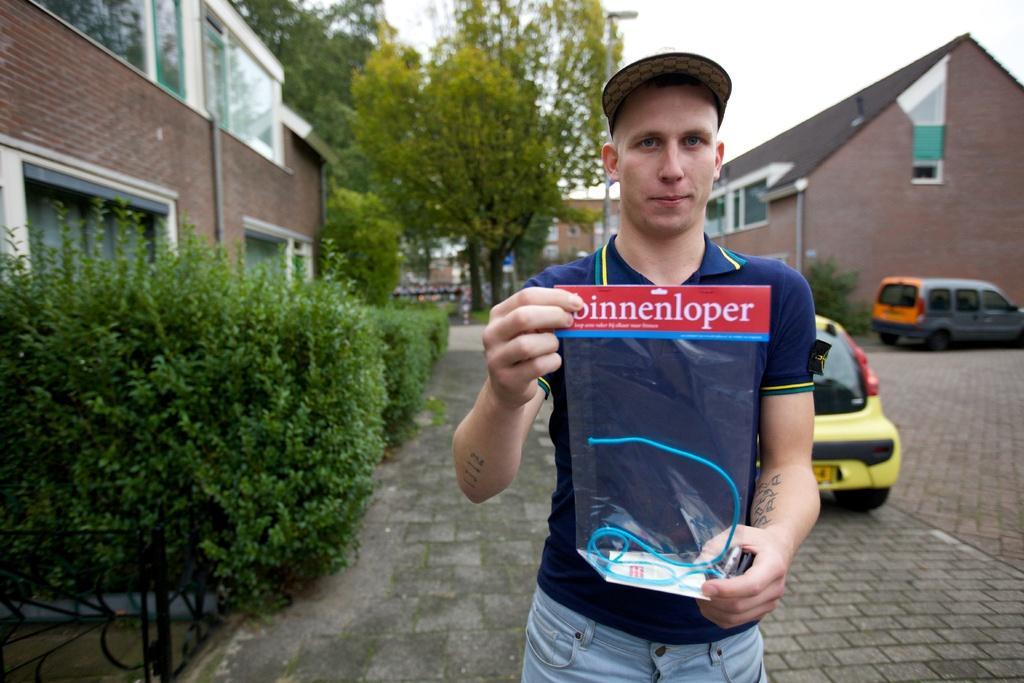Could you give a brief overview of what you see in this image? In this image I can see in the middle a man is holding a polythene cover, he is wearing a t-shirt and a cap. On the left side there are bushes and there is a building. On the right side there are vehicles, in the background there are trees. At the top there is the sky. 